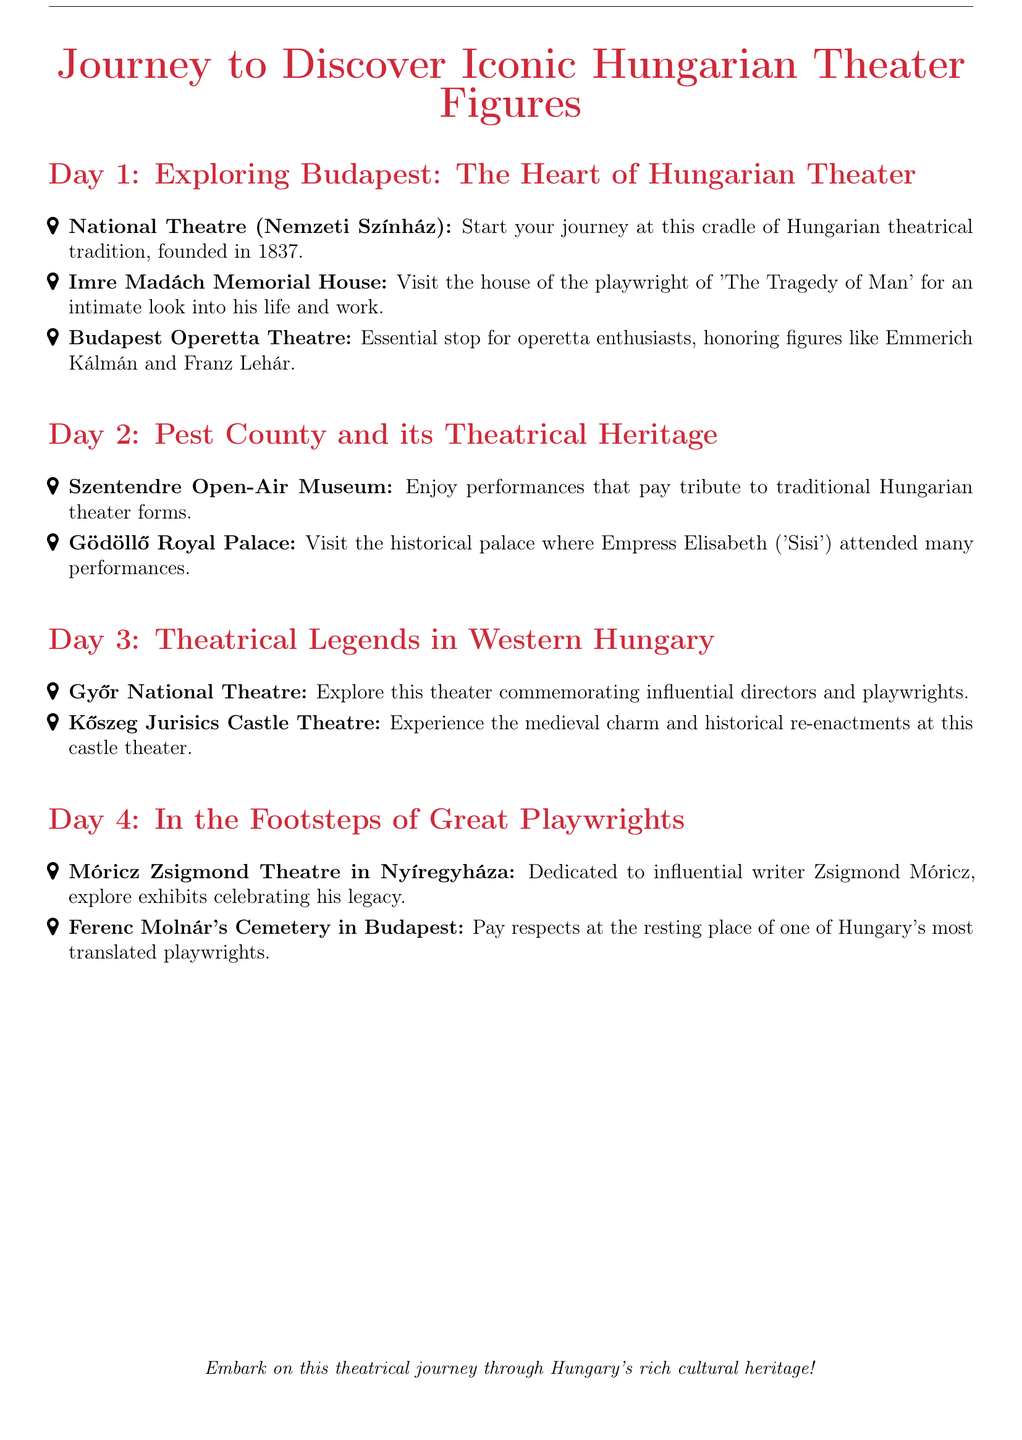What year was the National Theatre founded? The document states that the National Theatre was founded in 1837.
Answer: 1837 What is the name of the playwright associated with the Imre Madách Memorial House? The document mentions Imre Madách as the playwright of 'The Tragedy of Man'.
Answer: Imre Madách Which figure is honored at the Budapest Operetta Theatre? The document indicates that figures like Emmerich Kálmán are honored at this theatre.
Answer: Emmerich Kálmán What type of performances can be found at the Szentendre Open-Air Museum? The document mentions that performances pay tribute to traditional Hungarian theater forms at this site.
Answer: Traditional Hungarian theater forms What do visitors explore at the Móricz Zsigmond Theatre in Nyíregyháza? The document notes that visitors explore exhibits celebrating the legacy of Zsigmond Móricz.
Answer: Exhibits celebrating his legacy How many days is the journey in total? The itinerary covers four days of exploration, as outlined in the document.
Answer: Four days What is the final location listed on Day 4? The document lists Ferenc Molnár's Cemetery in Budapest as the final location for the journey.
Answer: Ferenc Molnár's Cemetery Which royal figure attended performances at the Gödöllő Royal Palace? The document states that Empress Elisabeth ('Sisi') attended many performances at this historical palace.
Answer: Empress Elisabeth ('Sisi') What type of theatre is celebrated at Kőszeg Jurisics Castle Theatre? The document highlights that this castle theater focuses on history and medieval charm.
Answer: Medieval charm and historical re-enactments 